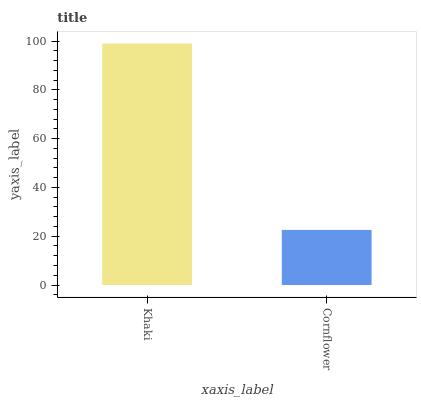Is Cornflower the minimum?
Answer yes or no. Yes. Is Khaki the maximum?
Answer yes or no. Yes. Is Cornflower the maximum?
Answer yes or no. No. Is Khaki greater than Cornflower?
Answer yes or no. Yes. Is Cornflower less than Khaki?
Answer yes or no. Yes. Is Cornflower greater than Khaki?
Answer yes or no. No. Is Khaki less than Cornflower?
Answer yes or no. No. Is Khaki the high median?
Answer yes or no. Yes. Is Cornflower the low median?
Answer yes or no. Yes. Is Cornflower the high median?
Answer yes or no. No. Is Khaki the low median?
Answer yes or no. No. 